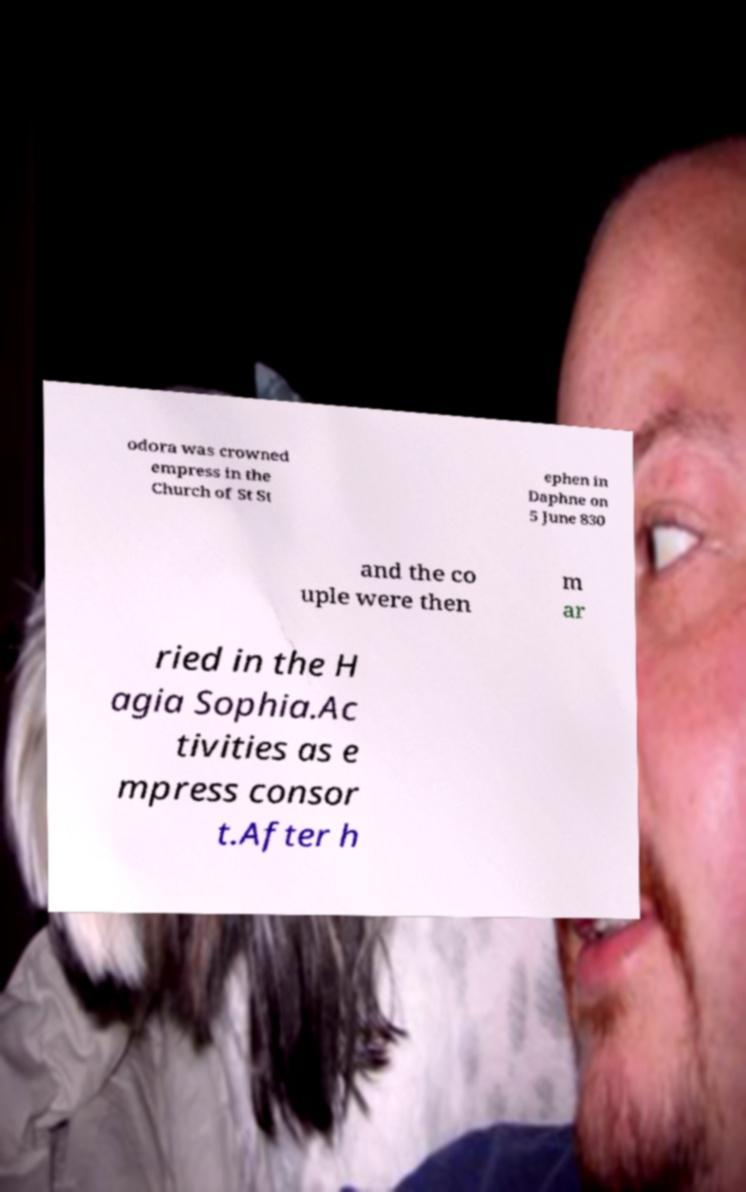Can you read and provide the text displayed in the image?This photo seems to have some interesting text. Can you extract and type it out for me? odora was crowned empress in the Church of St St ephen in Daphne on 5 June 830 and the co uple were then m ar ried in the H agia Sophia.Ac tivities as e mpress consor t.After h 